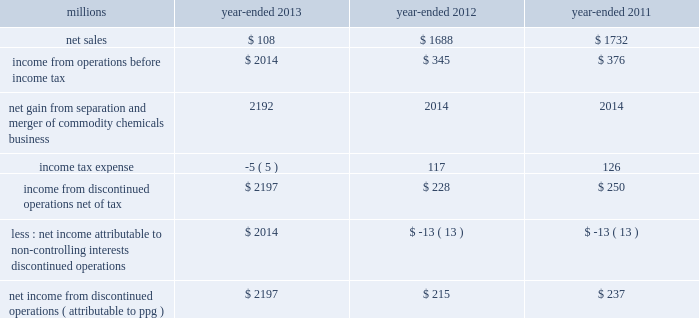74 2013 ppg annual report and form 10-k 22 .
Separation and merger transaction on january 28 , 2013 , the company completed the previously announced separation of its commodity chemicals business and merger of its wholly-owned subsidiary , eagle spinco inc. , with a subsidiary of georgia gulf corporation in a tax ef ficient reverse morris trust transaction ( the 201ctransaction 201d ) .
Pursuant to the merger , eagle spinco , the entity holding ppg's former commodity chemicals business , became a wholly-owned subsidiary of georgia gulf .
The closing of the merger followed the expiration of the related exchange offer and the satisfaction of certain other conditions .
The combined company formed by uniting georgia gulf with ppg's former commodity chemicals business is named axiall corporation ( 201caxiall 201d ) .
Ppg holds no ownership interest in axiall .
Ppg received the necessary ruling from the internal revenue service and as a result this transaction was generally tax free to ppg and its shareholders in the united states and canada .
Under the terms of the exchange offer , 35249104 shares of eagle spinco common stock were available for distribution in exchange for shares of ppg common stock accepted in the offer .
Following the merger , each share of eagle spinco common stock automatically converted into the right to receive one share of axiall corporation common stock .
Accordingly , ppg shareholders who tendered their shares of ppg common stock as part of this offer received 3.2562 shares of axiall common stock for each share of ppg common stock accepted for exchange .
Ppg was able to accept the maximum of 10825227 shares of ppg common stock for exchange in the offer , and thereby , reduced its outstanding shares by approximately 7% ( 7 % ) .
The completion of this exchange offer was a non-cash financing transaction , which resulted in an increase in "treasury stock" at a cost of $ 1.561 billion based on the ppg closing stock price on january 25 , 2013 .
Under the terms of the transaction , ppg received $ 900 million of cash and 35.2 million shares of axiall common stock ( market value of $ 1.8 billion on january 25 , 2013 ) which was distributed to ppg shareholders by the exchange offer as described above .
In addition , ppg received $ 67 million in cash for a preliminary post-closing working capital adjustment under the terms of the transaction agreements .
The net assets transferred to axiall included $ 27 million of cash on the books of the business transferred .
In the transaction , ppg transferred environmental remediation liabilities , defined benefit pension plan assets and liabilities and other post-employment benefit liabilities related to the commodity chemicals business to axiall .
During the first quarter of 2013 , ppg recorded a gain of $ 2.2 billion on the transaction reflecting the excess of the sum of the cash proceeds received and the cost ( closing stock price on january 25 , 2013 ) of the ppg shares tendered and accepted in the exchange for the 35.2 million shares of axiall common stock over the net book value of the net assets of ppg's former commodity chemicals business .
The transaction resulted in a net partial settlement loss of $ 33 million associated with the spin out and termination of defined benefit pension liabilities and the transfer of other post-retirement benefit liabilities under the terms of the transaction .
The company also incurred $ 14 million of pretax expense , primarily for professional services related to the transaction in 2013 as well as approximately $ 2 million of net expense related to certain retained obligations and post-closing adjustments under the terms of the transaction agreements .
The net gain on the transaction includes these related losses and expenses .
The results of operations and cash flows of ppg's former commodity chemicals business for january 2013 and the net gain on the transaction are reported as results from discontinued operations for the year -ended december 31 , 2013 .
In prior periods presented , the results of operations and cash flows of ppg's former commodity chemicals business have been reclassified from continuing operations and presented as results from discontinued operations .
Ppg will provide axiall with certain transition services for up to 24 months following the closing date of the transaction .
These services include logistics , purchasing , finance , information technology , human resources , tax and payroll processing .
The net sales and income before income taxes of the commodity chemicals business that have been reclassified and reported as discontinued operations are presented in the table below: .
Income from discontinued operations , net of tax $ 2197 $ 228 $ 250 less : net income attributable to non- controlling interests , discontinued operations $ 2014 $ ( 13 ) $ ( 13 ) net income from discontinued operations ( attributable to ppg ) $ 2197 $ 215 $ 237 during 2012 , $ 21 million of business separation costs are included within "income from discontinued operations , net." notes to the consolidated financial statements .
What was the total amount received by ppg in the axiall transaction , in millions? 
Computations: (((1.8 * 1000) + 900) + 67)
Answer: 2767.0. 